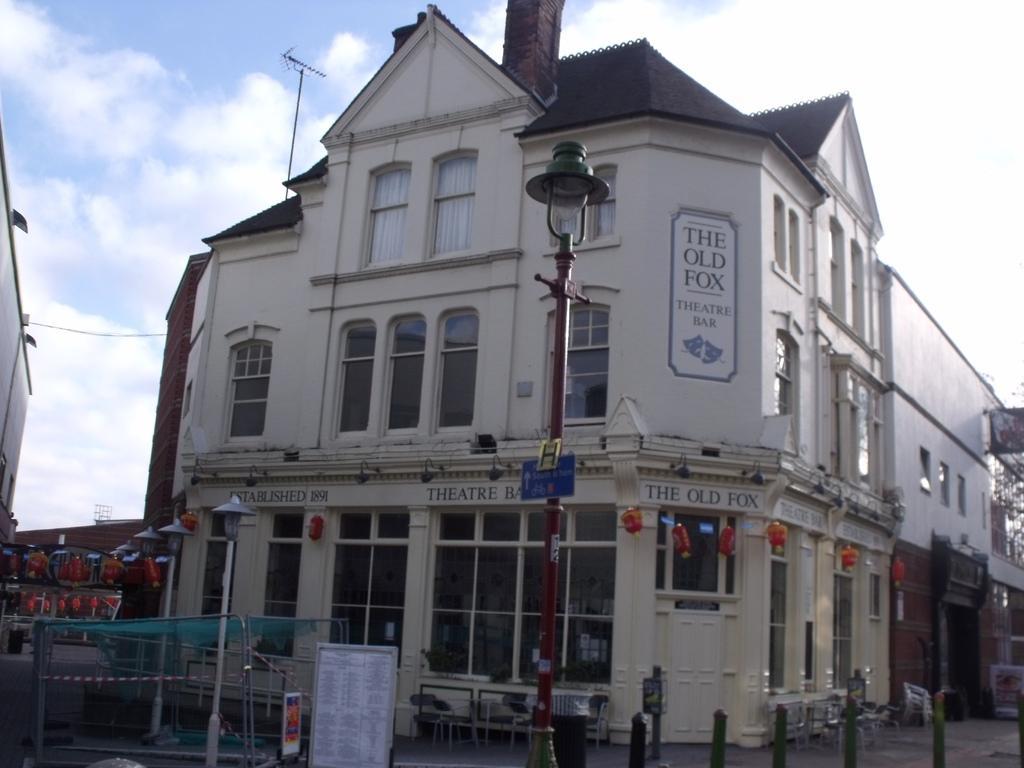Could you give a brief overview of what you see in this image? In the picture we can see the building with the glass windows and near it, we can see the pole with a lamp and some other poles and beside the building we can see another part of the building and in the background we can see the part of the sky with clouds. 